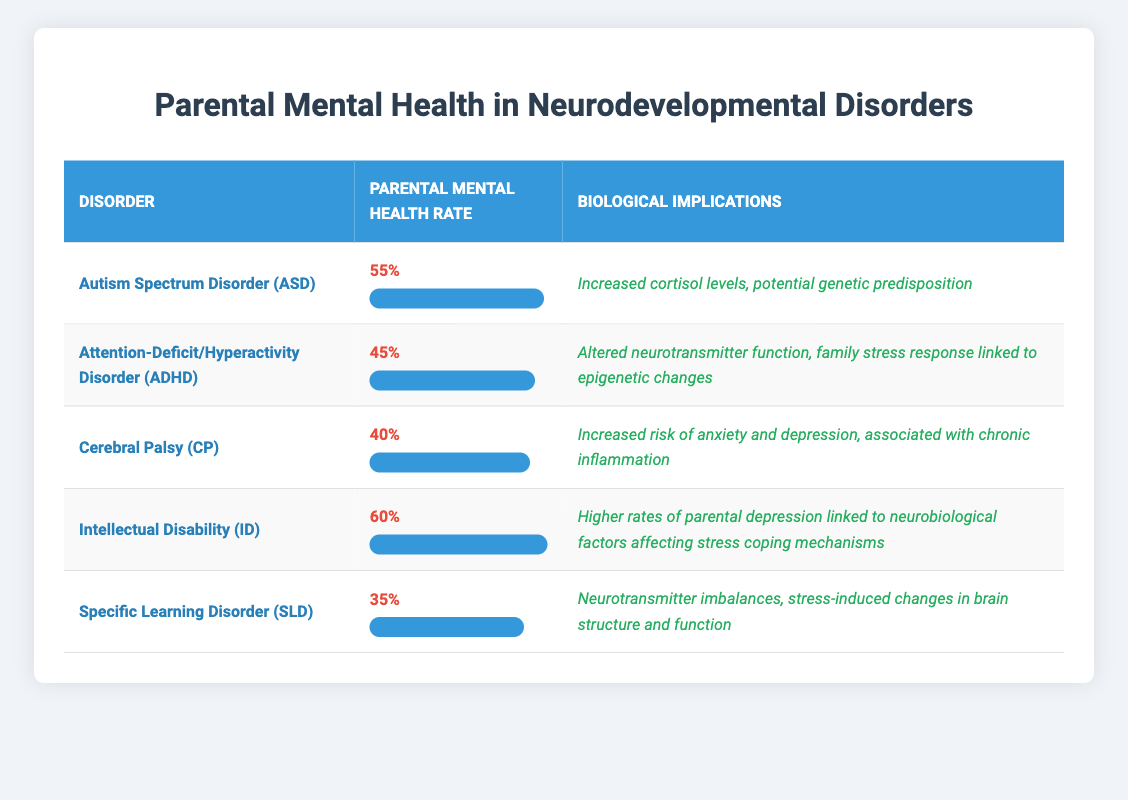What is the parental mental health rate for Autism Spectrum Disorder (ASD)? The table lists the parental mental health rate for Autism Spectrum Disorder (ASD) as 0.55 (or 55%).
Answer: 55% Which disorder has the highest parental mental health rate? By comparing the rates in the table, Intellectual Disability (ID) has the highest rate of 0.60 (or 60%).
Answer: Intellectual Disability (ID) Is the parental mental health rate for Specific Learning Disorder (SLD) higher than that for Cerebral Palsy (CP)? The parental mental health rate for Specific Learning Disorder (SLD) is 0.35 (or 35%), which is lower than the rate for Cerebral Palsy (CP) at 0.40 (or 40%). Therefore, the statement is false.
Answer: No What is the average parental mental health rate across all disorders listed? To calculate the average, sum the rates: 0.55 + 0.45 + 0.40 + 0.60 + 0.35 = 2.35. Then divide by the number of disorders (5): 2.35 / 5 = 0.47 (or 47%).
Answer: 47% What are the biological implications associated with Attention-Deficit/Hyperactivity Disorder (ADHD)? According to the table, the biological implications listed for ADHD include altered neurotransmitter function and family stress response linked to epigenetic changes.
Answer: Altered neurotransmitter function; family stress response linked to epigenetic changes Which disorder has the lowest parental mental health rate and what are its biological implications? The disorder with the lowest parental mental health rate is Specific Learning Disorder (SLD) at 0.35 (or 35%). The biological implications include neurotransmitter imbalances and stress-induced changes in brain structure and function.
Answer: Specific Learning Disorder (SLD); neurotransmitter imbalances; stress-induced changes in brain structure and function Are parents of children with Intellectual Disability (ID) at a higher risk for mental health issues than those of children with Autism Spectrum Disorder (ASD)? The parental mental health rate for Intellectual Disability (ID) is 0.60 (or 60%), while for Autism Spectrum Disorder (ASD) it is 0.55 (or 55%). This indicates parents of those with ID are at a higher risk for mental health issues.
Answer: Yes What is the difference in parental mental health rates between Intellectual Disability (ID) and Attention-Deficit/Hyperactivity Disorder (ADHD)? The rate for Intellectual Disability (ID) is 0.60, while that for ADHD is 0.45. The difference is 0.60 - 0.45 = 0.15 (or 15%).
Answer: 15% 